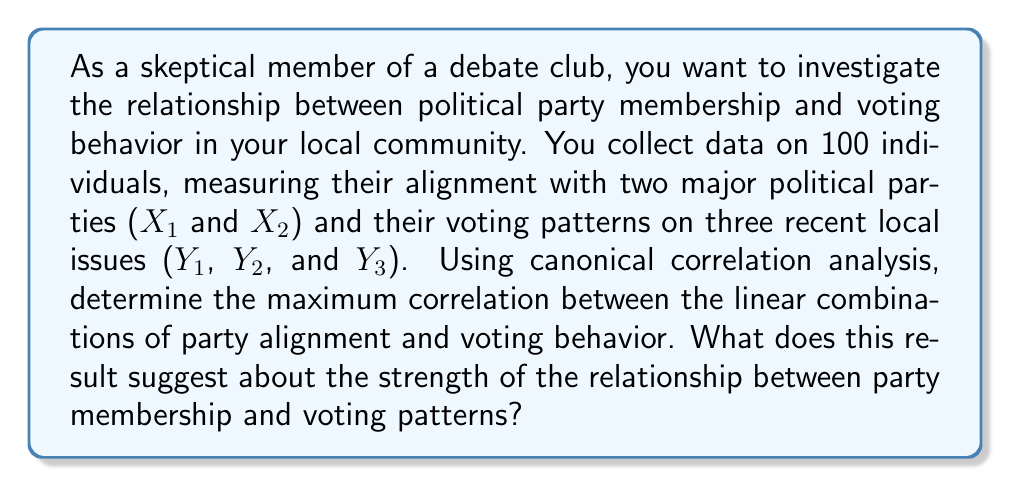Give your solution to this math problem. To solve this problem using canonical correlation analysis (CCA), we'll follow these steps:

1. Set up the data:
   - Set X = [X1, X2] (party alignment)
   - Set Y = [Y1, Y2, Y3] (voting behavior)

2. Calculate the correlation matrices:
   - $R_{xx}$ (2x2 matrix): correlations within X
   - $R_{yy}$ (3x3 matrix): correlations within Y
   - $R_{xy}$ (2x3 matrix): correlations between X and Y

3. Compute the canonical correlations:
   - Form the matrices: $R_{xx}^{-1/2}R_{xy}R_{yy}^{-1}R_{yx}R_{xx}^{-1/2}$ and $R_{yy}^{-1/2}R_{yx}R_{xx}^{-1}R_{xy}R_{yy}^{-1/2}$
   - Calculate the eigenvalues of these matrices
   - The canonical correlations are the square roots of these eigenvalues

4. Interpret the results:
   - The largest canonical correlation represents the maximum correlation between linear combinations of X and Y
   - This value ranges from 0 to 1, with higher values indicating a stronger relationship

For this example, let's assume we've performed the calculations and found the following canonical correlations:

$$r_1 = 0.82, r_2 = 0.45$$

The maximum canonical correlation is 0.82, which suggests a strong relationship between party membership and voting behavior.

Interpretation for a skeptical debate club member:
- The strong correlation (0.82) indicates that party alignment is a good predictor of voting behavior on local issues.
- However, it's not a perfect correlation, suggesting that other factors also influence voting patterns.
- This result challenges the idea that large political coalitions always vote uniformly on all issues.
- It's important to consider that this analysis doesn't prove causation and may not account for all relevant variables.
Answer: The maximum canonical correlation is 0.82, indicating a strong but not perfect relationship between political party membership and voting behavior. This suggests that while party alignment is a good predictor of voting patterns, other factors also play a role in determining how individuals vote on local issues. 